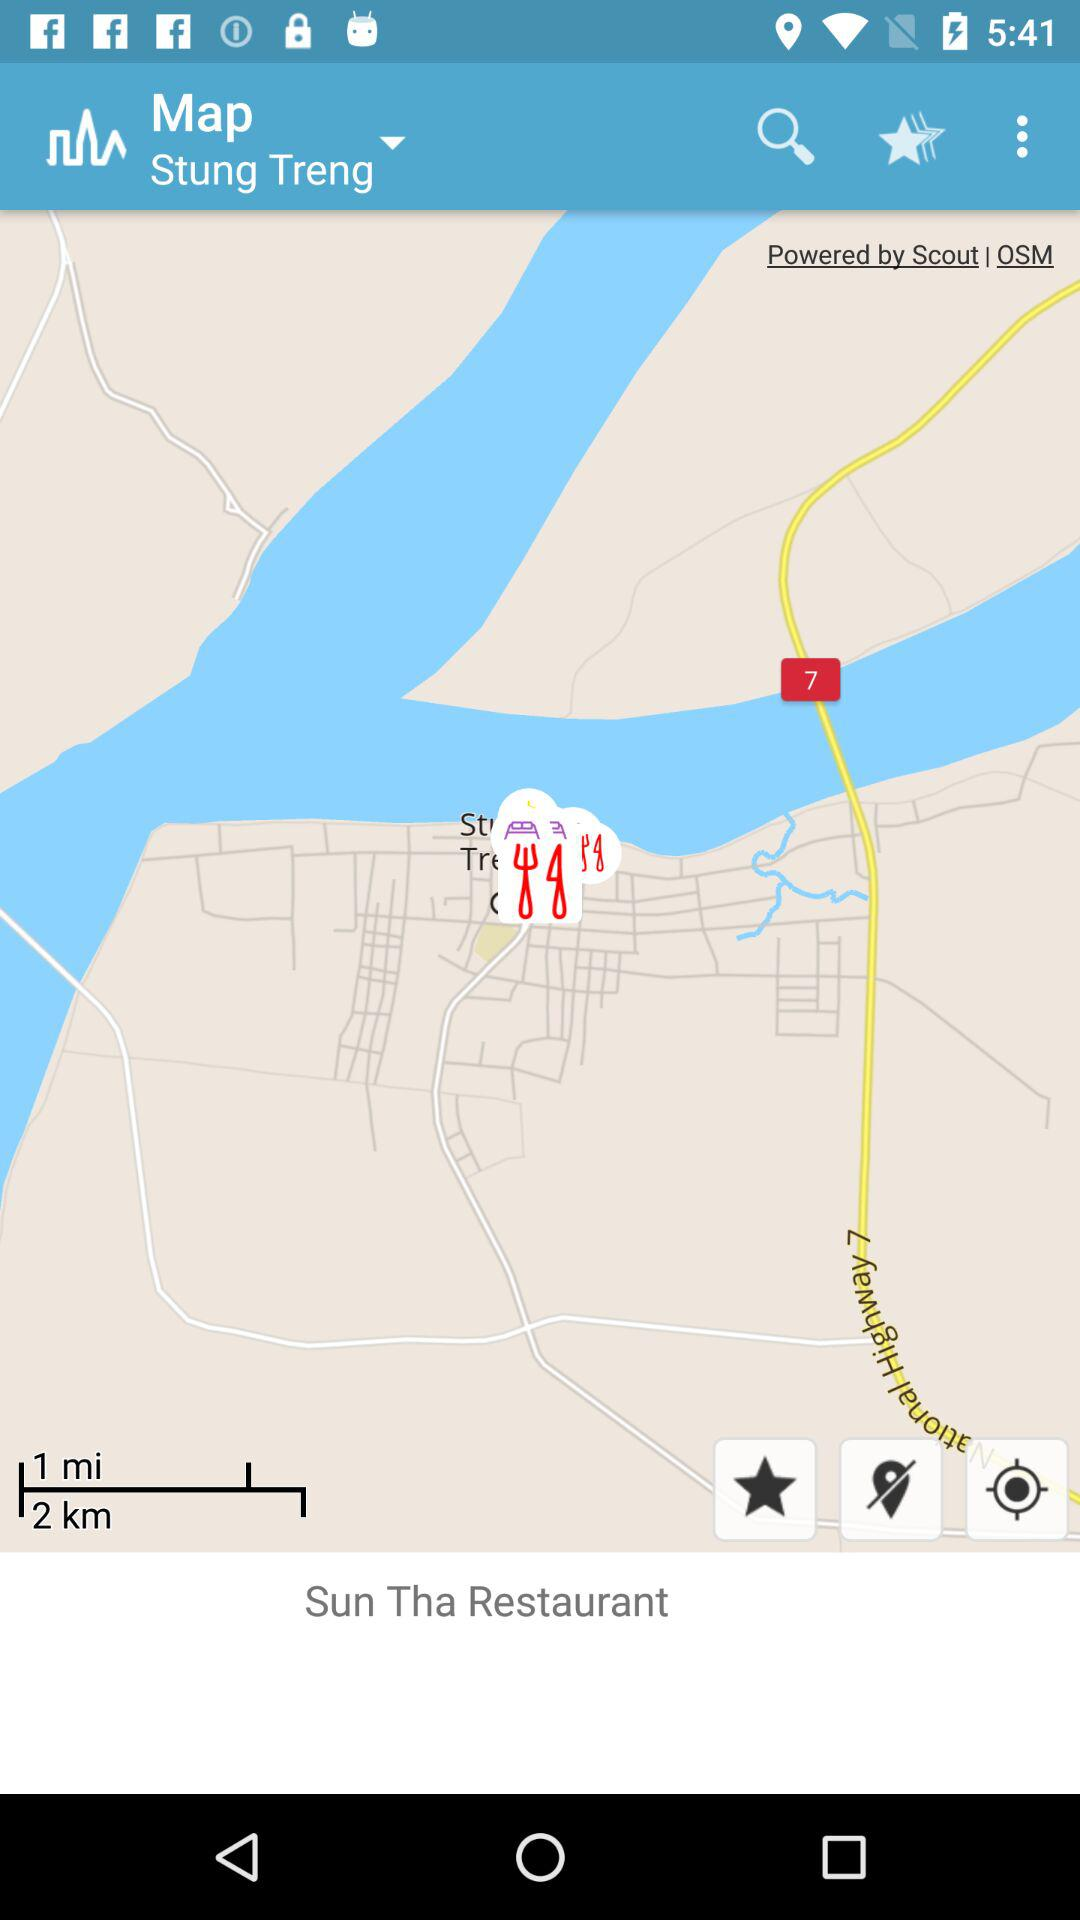What is the given distance? The given distances are 1 mile and 2 kilometers. 